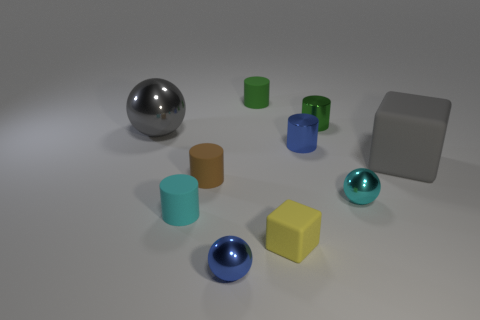Subtract 1 cylinders. How many cylinders are left? 4 Subtract all cyan matte cylinders. How many cylinders are left? 4 Subtract all brown cylinders. How many cylinders are left? 4 Subtract all yellow cylinders. Subtract all cyan balls. How many cylinders are left? 5 Subtract all blocks. How many objects are left? 8 Subtract all metallic cylinders. Subtract all small brown things. How many objects are left? 7 Add 9 big cubes. How many big cubes are left? 10 Add 3 tiny purple shiny cylinders. How many tiny purple shiny cylinders exist? 3 Subtract 0 blue cubes. How many objects are left? 10 